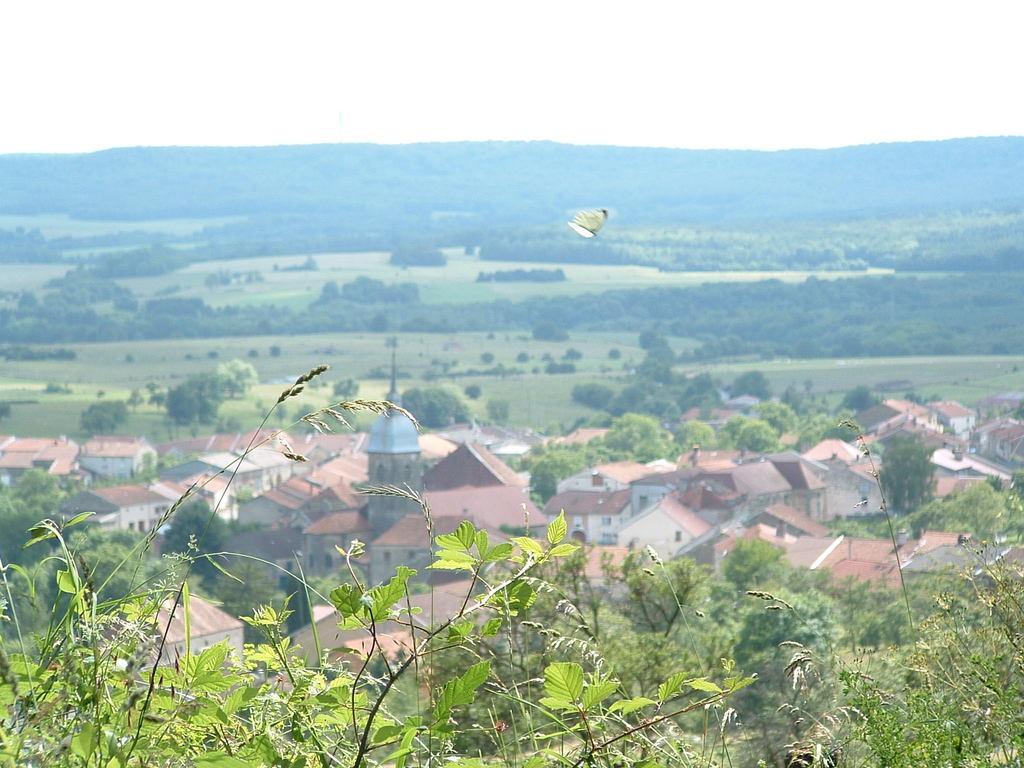Can you describe this image briefly? In this image, we can see a few plants. We can see a butterfly. There are a few houses. We can see the ground covered with grass. There are some trees. We can see the hills and the sky. 